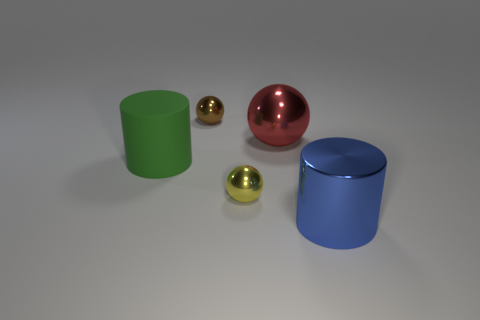Subtract all large red metal spheres. How many spheres are left? 2 Subtract 1 spheres. How many spheres are left? 2 Add 1 yellow spheres. How many objects exist? 6 Subtract all cylinders. How many objects are left? 3 Subtract all gray balls. Subtract all red cylinders. How many balls are left? 3 Subtract all blue metal spheres. Subtract all brown shiny spheres. How many objects are left? 4 Add 2 brown metal things. How many brown metal things are left? 3 Add 5 tiny yellow shiny spheres. How many tiny yellow shiny spheres exist? 6 Subtract 0 purple balls. How many objects are left? 5 